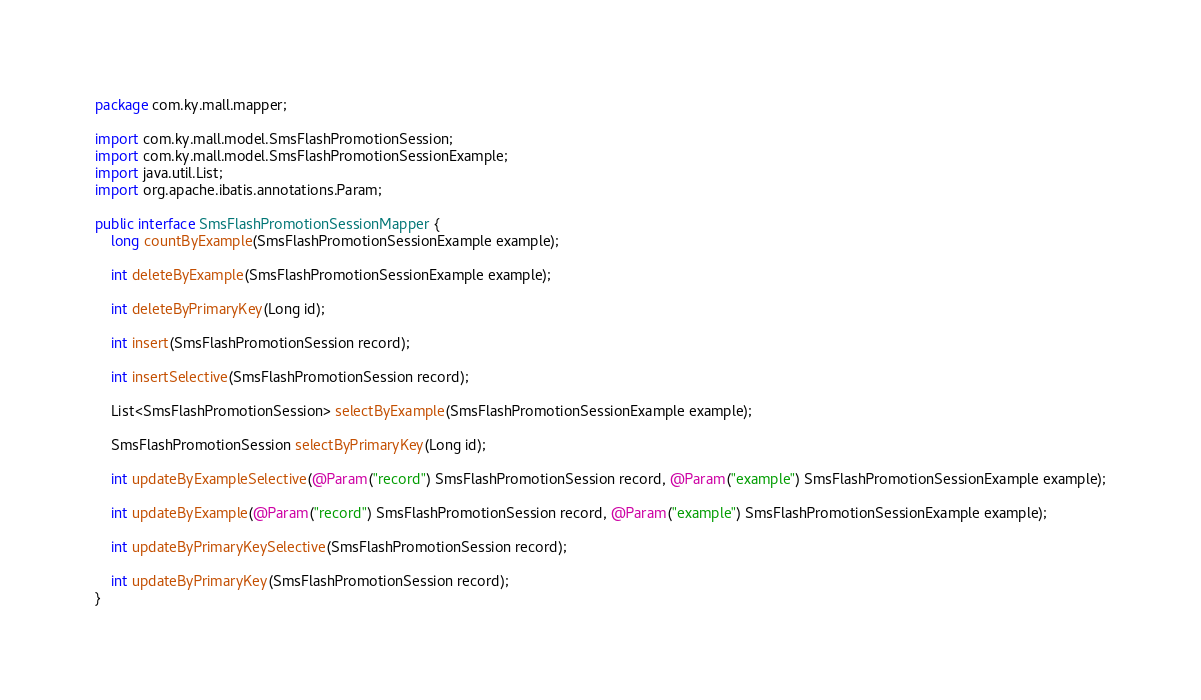Convert code to text. <code><loc_0><loc_0><loc_500><loc_500><_Java_>package com.ky.mall.mapper;

import com.ky.mall.model.SmsFlashPromotionSession;
import com.ky.mall.model.SmsFlashPromotionSessionExample;
import java.util.List;
import org.apache.ibatis.annotations.Param;

public interface SmsFlashPromotionSessionMapper {
    long countByExample(SmsFlashPromotionSessionExample example);

    int deleteByExample(SmsFlashPromotionSessionExample example);

    int deleteByPrimaryKey(Long id);

    int insert(SmsFlashPromotionSession record);

    int insertSelective(SmsFlashPromotionSession record);

    List<SmsFlashPromotionSession> selectByExample(SmsFlashPromotionSessionExample example);

    SmsFlashPromotionSession selectByPrimaryKey(Long id);

    int updateByExampleSelective(@Param("record") SmsFlashPromotionSession record, @Param("example") SmsFlashPromotionSessionExample example);

    int updateByExample(@Param("record") SmsFlashPromotionSession record, @Param("example") SmsFlashPromotionSessionExample example);

    int updateByPrimaryKeySelective(SmsFlashPromotionSession record);

    int updateByPrimaryKey(SmsFlashPromotionSession record);
}</code> 